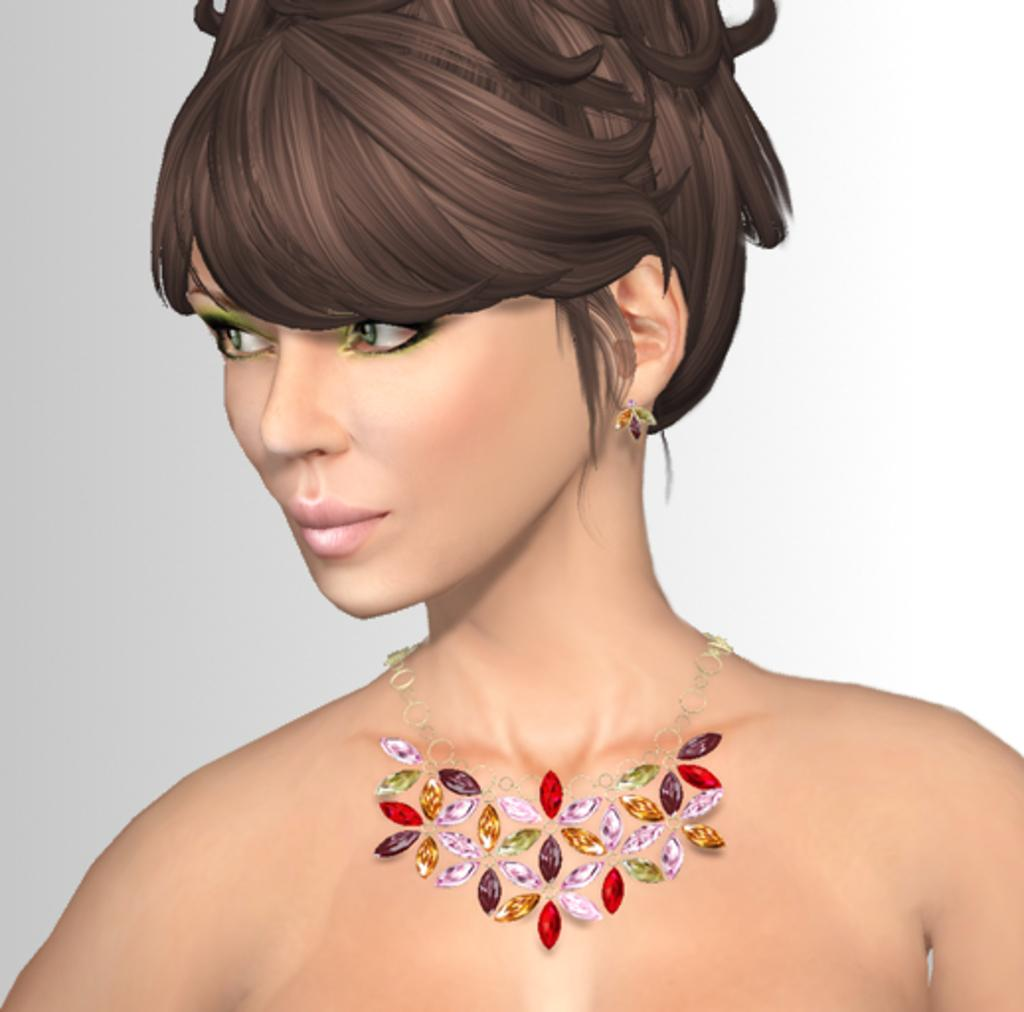What type of image is being described? The image is animated. Who or what is present in the image? There is a woman in the image. What accessory is the woman wearing? There is a necklace in the image. What type of wrench is the woman using in the image? There is no wrench present in the image. Can you tell me the relationship between the woman and the parent in the image? There is no mention of a parent in the image, as the only subject described is the woman. 